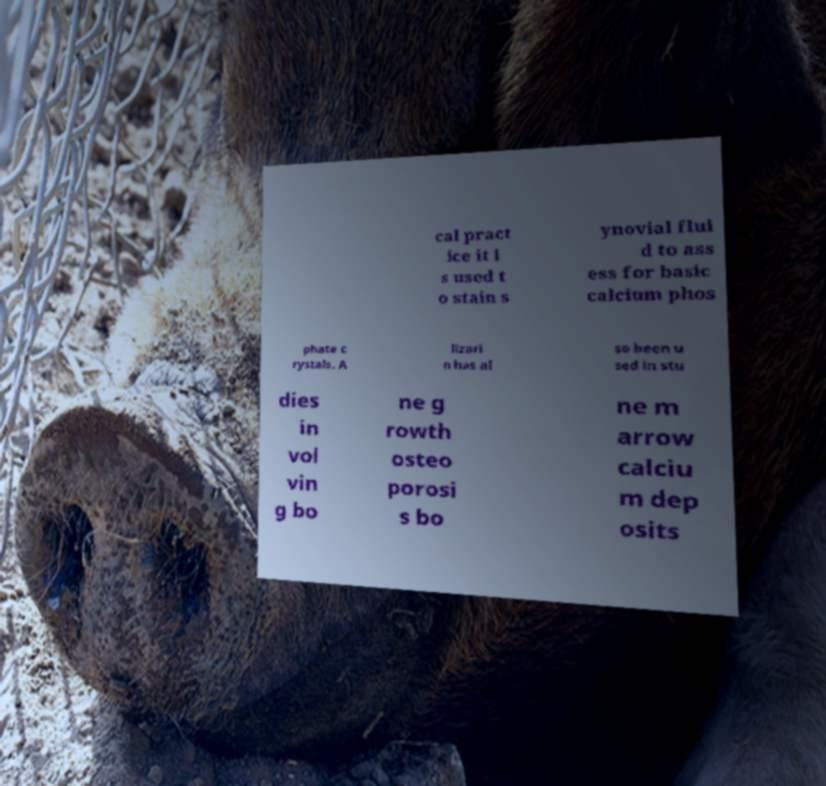For documentation purposes, I need the text within this image transcribed. Could you provide that? cal pract ice it i s used t o stain s ynovial flui d to ass ess for basic calcium phos phate c rystals. A lizari n has al so been u sed in stu dies in vol vin g bo ne g rowth osteo porosi s bo ne m arrow calciu m dep osits 